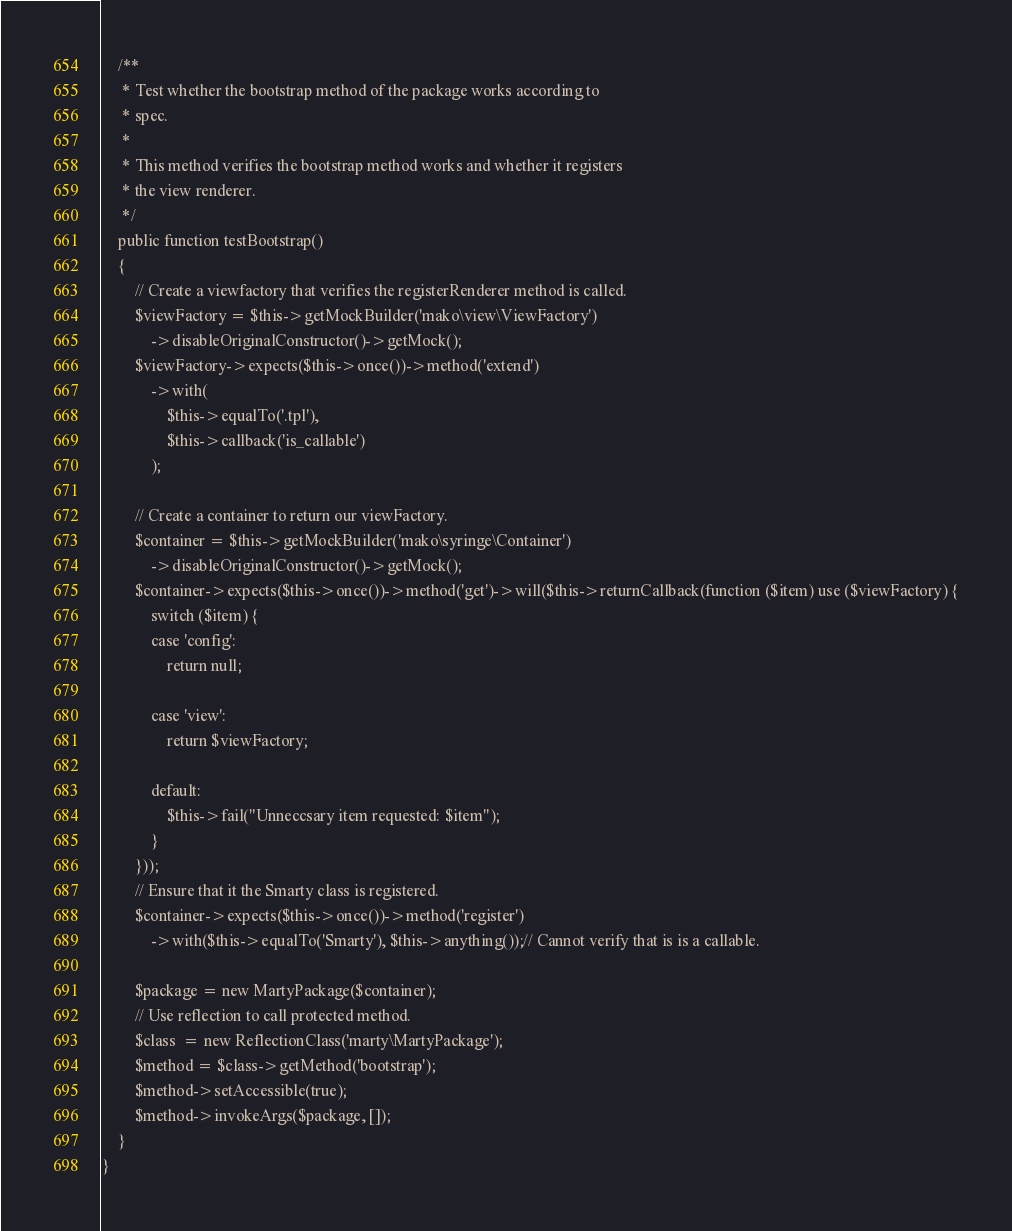<code> <loc_0><loc_0><loc_500><loc_500><_PHP_>
    /**
     * Test whether the bootstrap method of the package works according to
     * spec.
     *
     * This method verifies the bootstrap method works and whether it registers
     * the view renderer.
     */
    public function testBootstrap()
    {
        // Create a viewfactory that verifies the registerRenderer method is called.
        $viewFactory = $this->getMockBuilder('mako\view\ViewFactory')
            ->disableOriginalConstructor()->getMock();
        $viewFactory->expects($this->once())->method('extend')
            ->with(
                $this->equalTo('.tpl'),
                $this->callback('is_callable')
            );

        // Create a container to return our viewFactory.
        $container = $this->getMockBuilder('mako\syringe\Container')
            ->disableOriginalConstructor()->getMock();
        $container->expects($this->once())->method('get')->will($this->returnCallback(function ($item) use ($viewFactory) {
            switch ($item) {
            case 'config':
                return null;

            case 'view':
                return $viewFactory;

            default:
                $this->fail("Unneccsary item requested: $item");
            }
        }));
        // Ensure that it the Smarty class is registered.
        $container->expects($this->once())->method('register')
            ->with($this->equalTo('Smarty'), $this->anything());// Cannot verify that is is a callable.

        $package = new MartyPackage($container);
        // Use reflection to call protected method.
        $class  = new ReflectionClass('marty\MartyPackage');
        $method = $class->getMethod('bootstrap');
        $method->setAccessible(true);
        $method->invokeArgs($package, []);
    }
}
</code> 